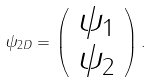Convert formula to latex. <formula><loc_0><loc_0><loc_500><loc_500>\psi _ { 2 D } = \left ( \begin{array} { c } \psi _ { 1 } \\ \psi _ { 2 } \end{array} \right ) .</formula> 